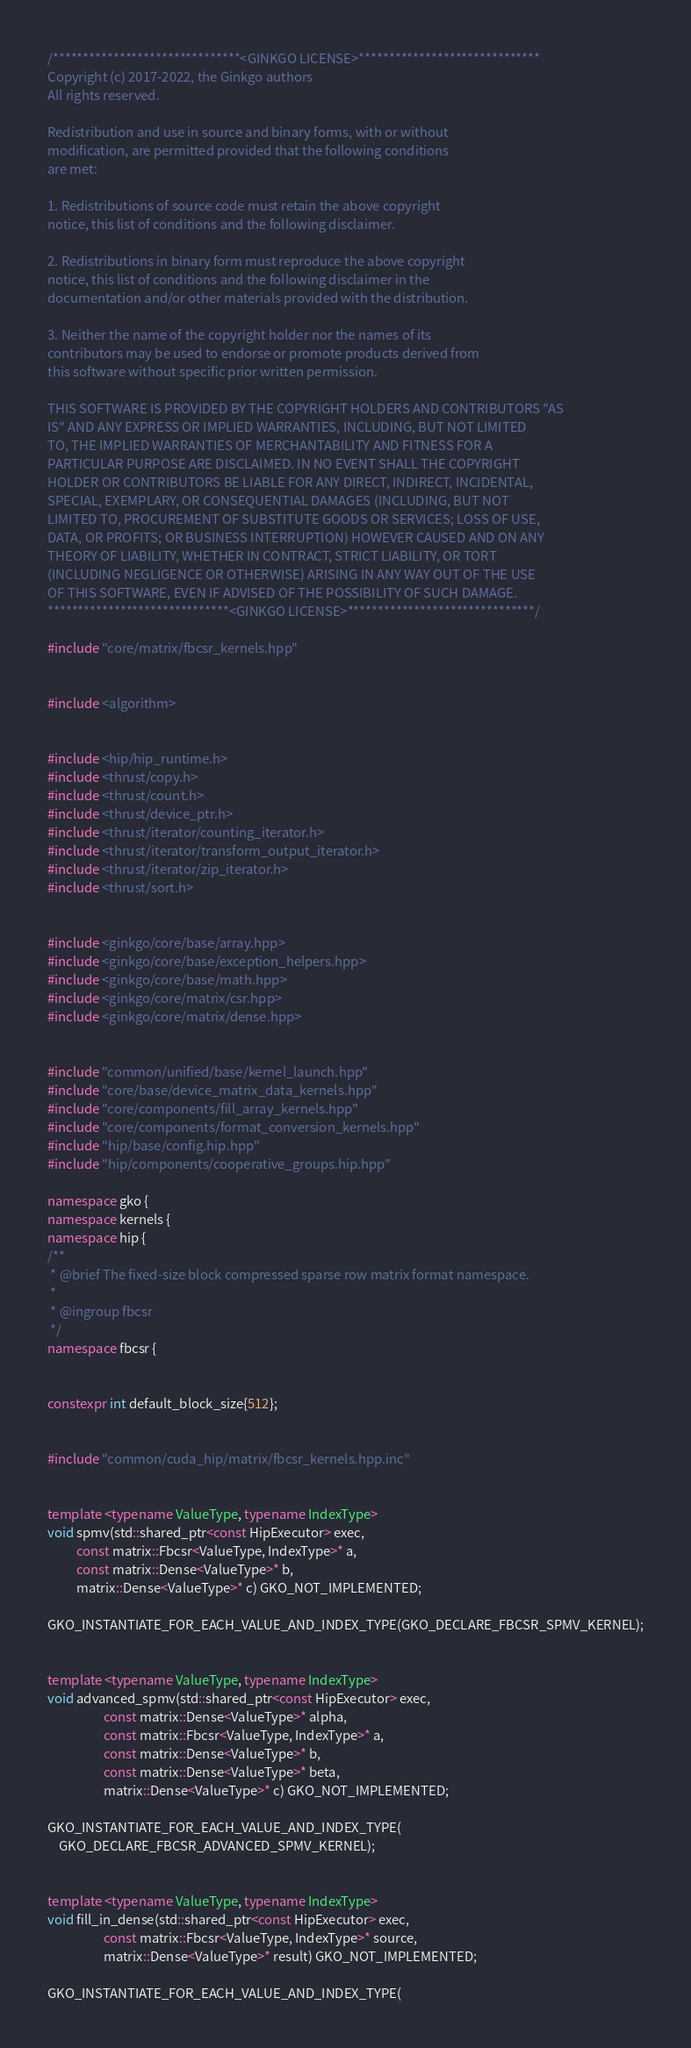Convert code to text. <code><loc_0><loc_0><loc_500><loc_500><_C++_>/*******************************<GINKGO LICENSE>******************************
Copyright (c) 2017-2022, the Ginkgo authors
All rights reserved.

Redistribution and use in source and binary forms, with or without
modification, are permitted provided that the following conditions
are met:

1. Redistributions of source code must retain the above copyright
notice, this list of conditions and the following disclaimer.

2. Redistributions in binary form must reproduce the above copyright
notice, this list of conditions and the following disclaimer in the
documentation and/or other materials provided with the distribution.

3. Neither the name of the copyright holder nor the names of its
contributors may be used to endorse or promote products derived from
this software without specific prior written permission.

THIS SOFTWARE IS PROVIDED BY THE COPYRIGHT HOLDERS AND CONTRIBUTORS "AS
IS" AND ANY EXPRESS OR IMPLIED WARRANTIES, INCLUDING, BUT NOT LIMITED
TO, THE IMPLIED WARRANTIES OF MERCHANTABILITY AND FITNESS FOR A
PARTICULAR PURPOSE ARE DISCLAIMED. IN NO EVENT SHALL THE COPYRIGHT
HOLDER OR CONTRIBUTORS BE LIABLE FOR ANY DIRECT, INDIRECT, INCIDENTAL,
SPECIAL, EXEMPLARY, OR CONSEQUENTIAL DAMAGES (INCLUDING, BUT NOT
LIMITED TO, PROCUREMENT OF SUBSTITUTE GOODS OR SERVICES; LOSS OF USE,
DATA, OR PROFITS; OR BUSINESS INTERRUPTION) HOWEVER CAUSED AND ON ANY
THEORY OF LIABILITY, WHETHER IN CONTRACT, STRICT LIABILITY, OR TORT
(INCLUDING NEGLIGENCE OR OTHERWISE) ARISING IN ANY WAY OUT OF THE USE
OF THIS SOFTWARE, EVEN IF ADVISED OF THE POSSIBILITY OF SUCH DAMAGE.
******************************<GINKGO LICENSE>*******************************/

#include "core/matrix/fbcsr_kernels.hpp"


#include <algorithm>


#include <hip/hip_runtime.h>
#include <thrust/copy.h>
#include <thrust/count.h>
#include <thrust/device_ptr.h>
#include <thrust/iterator/counting_iterator.h>
#include <thrust/iterator/transform_output_iterator.h>
#include <thrust/iterator/zip_iterator.h>
#include <thrust/sort.h>


#include <ginkgo/core/base/array.hpp>
#include <ginkgo/core/base/exception_helpers.hpp>
#include <ginkgo/core/base/math.hpp>
#include <ginkgo/core/matrix/csr.hpp>
#include <ginkgo/core/matrix/dense.hpp>


#include "common/unified/base/kernel_launch.hpp"
#include "core/base/device_matrix_data_kernels.hpp"
#include "core/components/fill_array_kernels.hpp"
#include "core/components/format_conversion_kernels.hpp"
#include "hip/base/config.hip.hpp"
#include "hip/components/cooperative_groups.hip.hpp"

namespace gko {
namespace kernels {
namespace hip {
/**
 * @brief The fixed-size block compressed sparse row matrix format namespace.
 *
 * @ingroup fbcsr
 */
namespace fbcsr {


constexpr int default_block_size{512};


#include "common/cuda_hip/matrix/fbcsr_kernels.hpp.inc"


template <typename ValueType, typename IndexType>
void spmv(std::shared_ptr<const HipExecutor> exec,
          const matrix::Fbcsr<ValueType, IndexType>* a,
          const matrix::Dense<ValueType>* b,
          matrix::Dense<ValueType>* c) GKO_NOT_IMPLEMENTED;

GKO_INSTANTIATE_FOR_EACH_VALUE_AND_INDEX_TYPE(GKO_DECLARE_FBCSR_SPMV_KERNEL);


template <typename ValueType, typename IndexType>
void advanced_spmv(std::shared_ptr<const HipExecutor> exec,
                   const matrix::Dense<ValueType>* alpha,
                   const matrix::Fbcsr<ValueType, IndexType>* a,
                   const matrix::Dense<ValueType>* b,
                   const matrix::Dense<ValueType>* beta,
                   matrix::Dense<ValueType>* c) GKO_NOT_IMPLEMENTED;

GKO_INSTANTIATE_FOR_EACH_VALUE_AND_INDEX_TYPE(
    GKO_DECLARE_FBCSR_ADVANCED_SPMV_KERNEL);


template <typename ValueType, typename IndexType>
void fill_in_dense(std::shared_ptr<const HipExecutor> exec,
                   const matrix::Fbcsr<ValueType, IndexType>* source,
                   matrix::Dense<ValueType>* result) GKO_NOT_IMPLEMENTED;

GKO_INSTANTIATE_FOR_EACH_VALUE_AND_INDEX_TYPE(</code> 